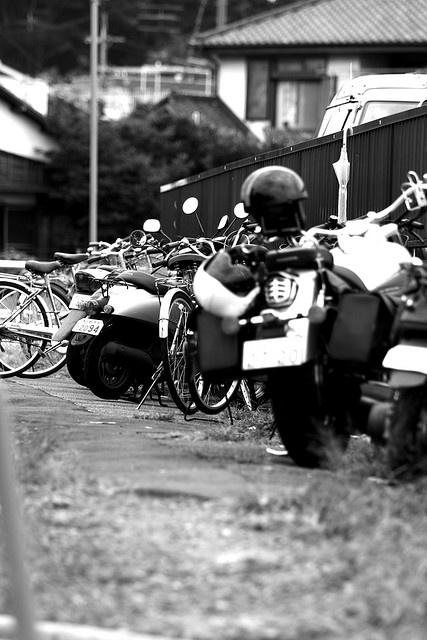Describe the objects in this image and their specific colors. I can see motorcycle in black, white, gray, and darkgray tones, motorcycle in black, gray, and white tones, motorcycle in black, whitesmoke, gray, and darkgray tones, bicycle in black, white, darkgray, and gray tones, and truck in black, white, darkgray, and gray tones in this image. 